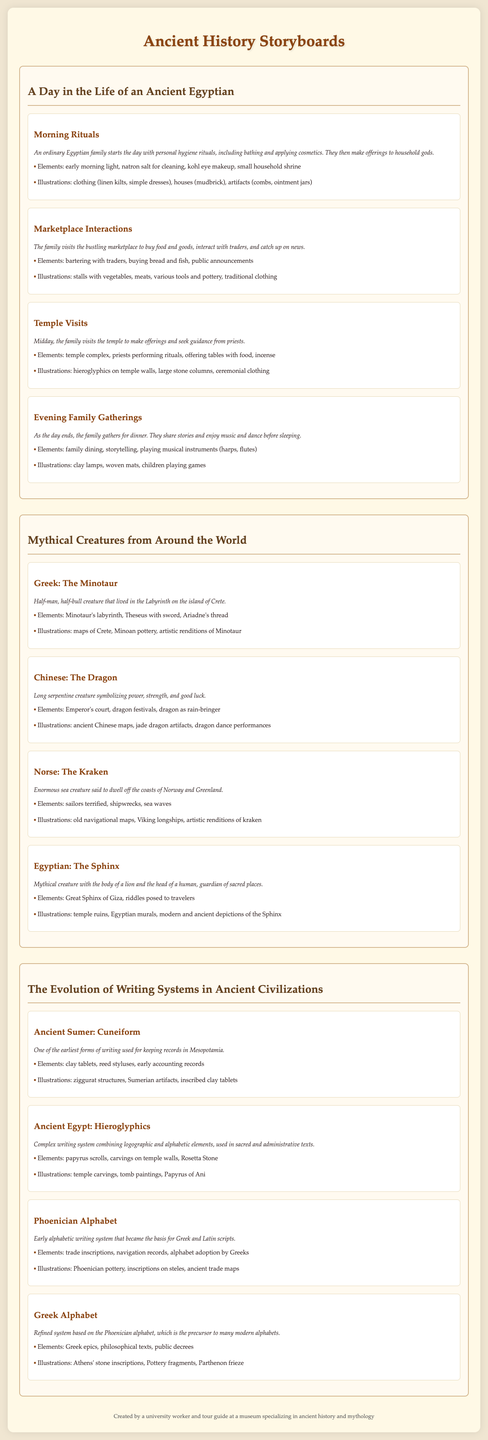What is the storyboard title featuring morning rituals? The title for the storyboard that includes morning rituals is "A Day in the Life of an Ancient Egyptian."
Answer: A Day in the Life of an Ancient Egyptian Which mythical creature is associated with the island of Crete? The mythical creature related to Crete is the Minotaur, who lived in a labyrinth on the island.
Answer: Minotaur What writing system did Ancient Sumerians use? The writing system used by Ancient Sumerians for keeping records is cuneiform.
Answer: Cuneiform What is the key temple structure highlighted in the Acropolis of Athens? The key temple structure emphasized in the Acropolis of Athens is the Parthenon.
Answer: Parthenon Which festival is depicted in the role of mythology in ancient rituals? The festival depicted in the role of mythology is the Roman Saturnalia.
Answer: Roman Saturnalia What mythical creature has a body of a lion and a human head? The mythical creature with the body of a lion and the head of a human is the Sphinx.
Answer: Sphinx What elements are associated with family gatherings in Ancient Egypt? The elements associated with family gatherings include dining, storytelling, and playing musical instruments.
Answer: family dining, storytelling, playing musical instruments Which materials were used for Ancient Egyptian writing? The materials used for writing in Ancient Egypt included papyrus scrolls and carvings on temple walls.
Answer: papyrus scrolls, carvings on temple walls What is the main function of the Kraken in Norse mythology? The main function of the Kraken in Norse mythology is to dwell in the sea and cause shipwrecks.
Answer: dwell in the sea and cause shipwrecks 